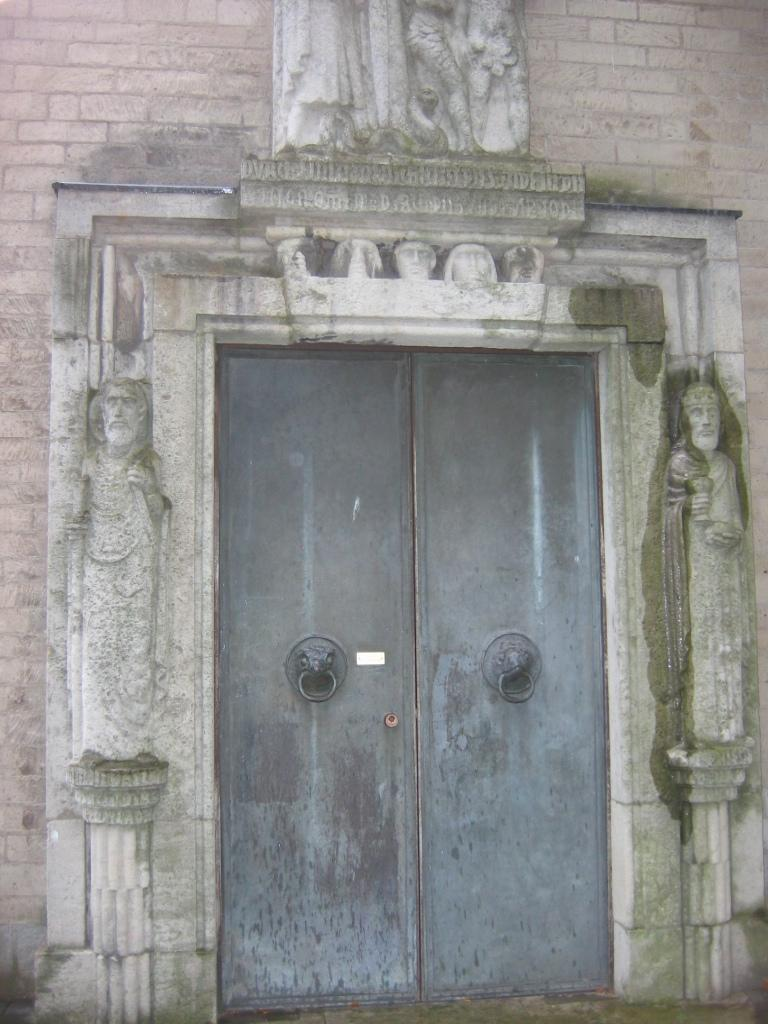What is the main subject of the image? The main subject of the image is the front door of a building. What can be seen on either side of the front door? There are walls on either side of the front door. What decorative features are present on the walls? The walls have carvings on them. What type of furniture can be seen inside the building through the front door? There is no furniture visible inside the building through the front door in the image. What is the mouth of the person doing in the image? There is no person or mouth present in the image. 